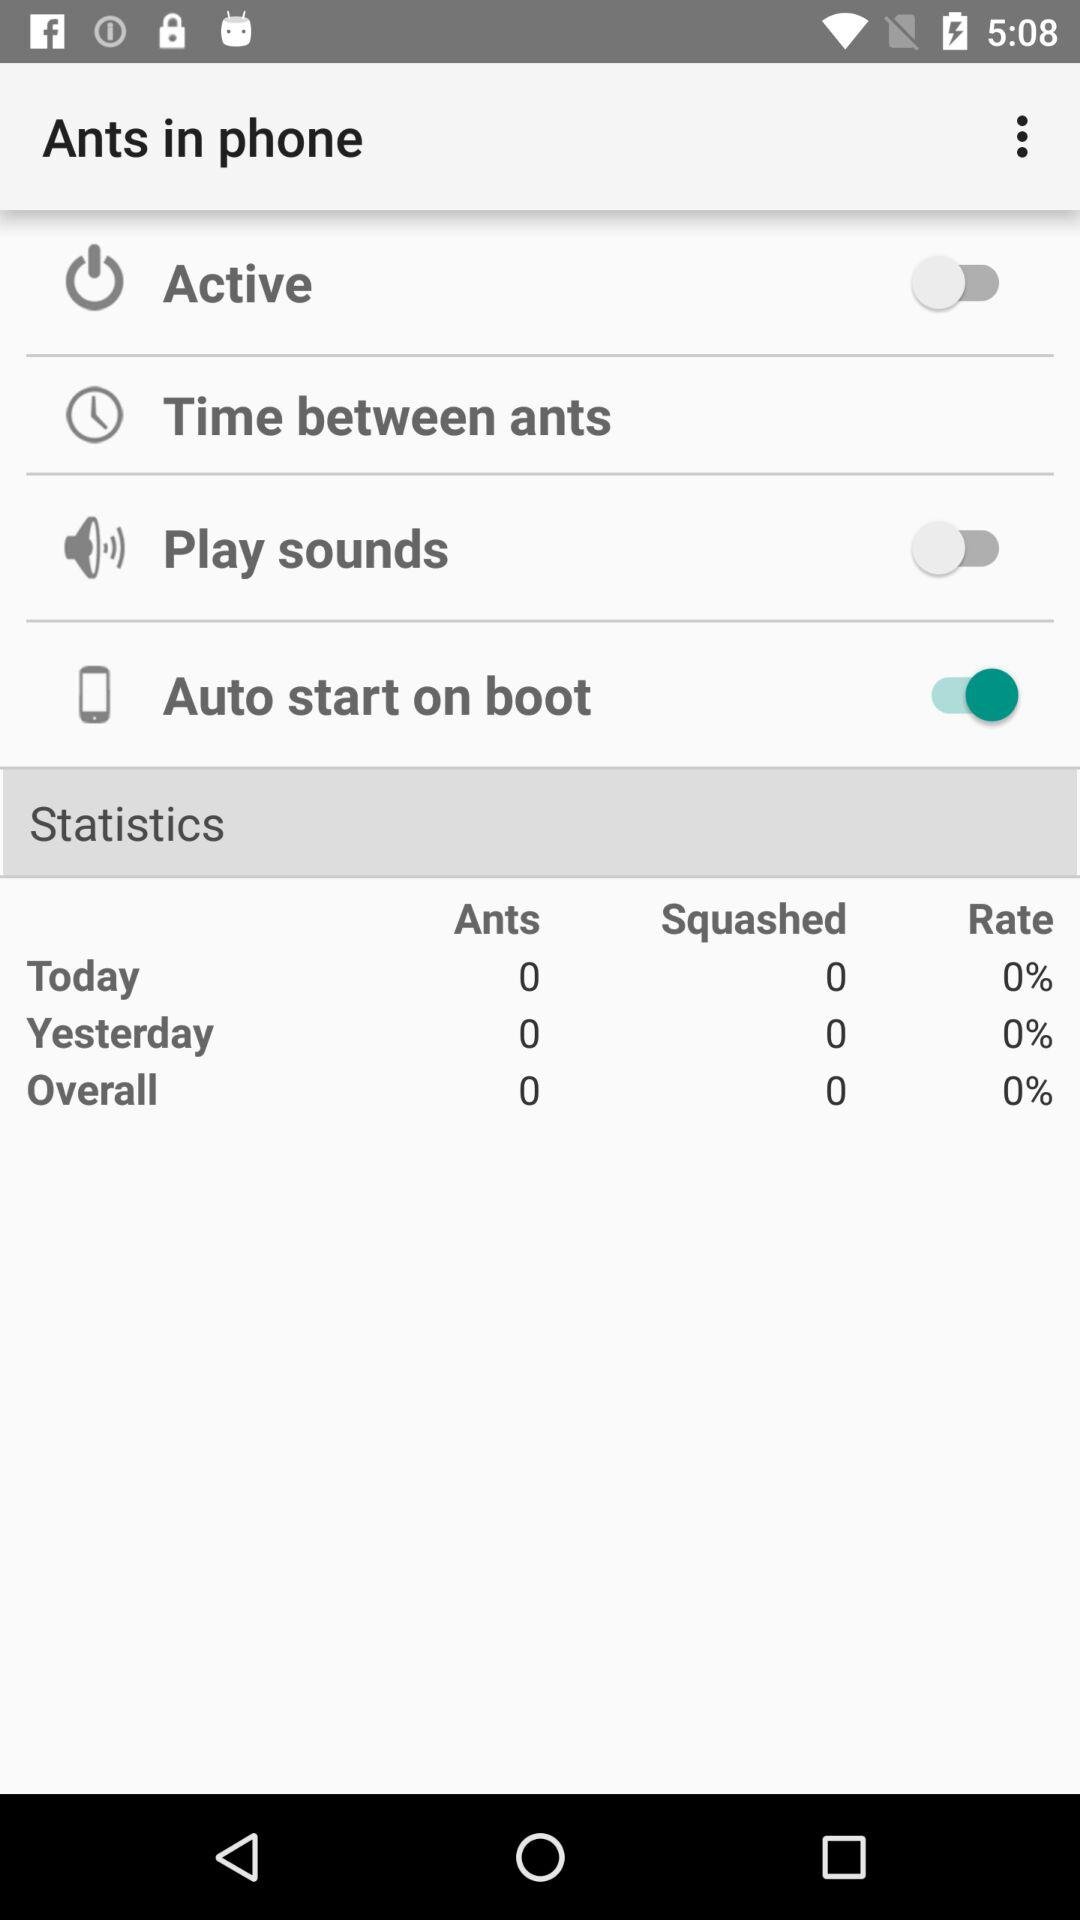How many percent of ants have been squashed today?
Answer the question using a single word or phrase. 0% 